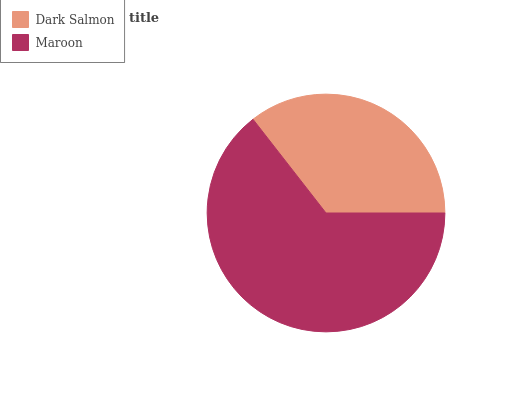Is Dark Salmon the minimum?
Answer yes or no. Yes. Is Maroon the maximum?
Answer yes or no. Yes. Is Maroon the minimum?
Answer yes or no. No. Is Maroon greater than Dark Salmon?
Answer yes or no. Yes. Is Dark Salmon less than Maroon?
Answer yes or no. Yes. Is Dark Salmon greater than Maroon?
Answer yes or no. No. Is Maroon less than Dark Salmon?
Answer yes or no. No. Is Maroon the high median?
Answer yes or no. Yes. Is Dark Salmon the low median?
Answer yes or no. Yes. Is Dark Salmon the high median?
Answer yes or no. No. Is Maroon the low median?
Answer yes or no. No. 